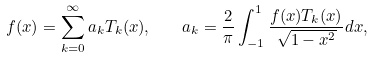Convert formula to latex. <formula><loc_0><loc_0><loc_500><loc_500>f ( x ) = \sum _ { k = 0 } ^ { \infty } a _ { k } T _ { k } ( x ) , \quad a _ { k } = \frac { 2 } { \pi } \int _ { - 1 } ^ { 1 } \frac { f ( x ) T _ { k } ( x ) } { \sqrt { 1 - x ^ { 2 } } } d x ,</formula> 